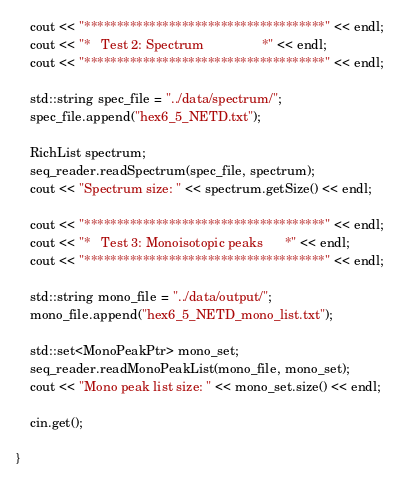Convert code to text. <code><loc_0><loc_0><loc_500><loc_500><_C++_>	cout << "*************************************" << endl;
	cout << "*   Test 2: Spectrum                *" << endl;
	cout << "*************************************" << endl;

	std::string spec_file = "../data/spectrum/";
	spec_file.append("hex6_5_NETD.txt");

	RichList spectrum;
	seq_reader.readSpectrum(spec_file, spectrum);
	cout << "Spectrum size: " << spectrum.getSize() << endl;

	cout << "*************************************" << endl;
	cout << "*   Test 3: Monoisotopic peaks      *" << endl;
	cout << "*************************************" << endl;

	std::string mono_file = "../data/output/";
	mono_file.append("hex6_5_NETD_mono_list.txt");

	std::set<MonoPeakPtr> mono_set;
	seq_reader.readMonoPeakList(mono_file, mono_set);
	cout << "Mono peak list size: " << mono_set.size() << endl;

	cin.get();
	
}</code> 